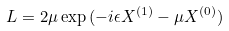<formula> <loc_0><loc_0><loc_500><loc_500>L = 2 \mu \exp { ( - i \epsilon X ^ { ( 1 ) } - \mu X ^ { ( 0 ) } ) }</formula> 